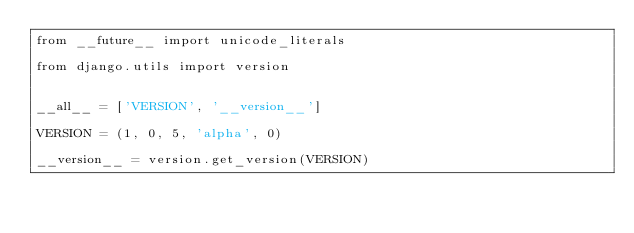<code> <loc_0><loc_0><loc_500><loc_500><_Python_>from __future__ import unicode_literals

from django.utils import version


__all__ = ['VERSION', '__version__']

VERSION = (1, 0, 5, 'alpha', 0)

__version__ = version.get_version(VERSION)
</code> 